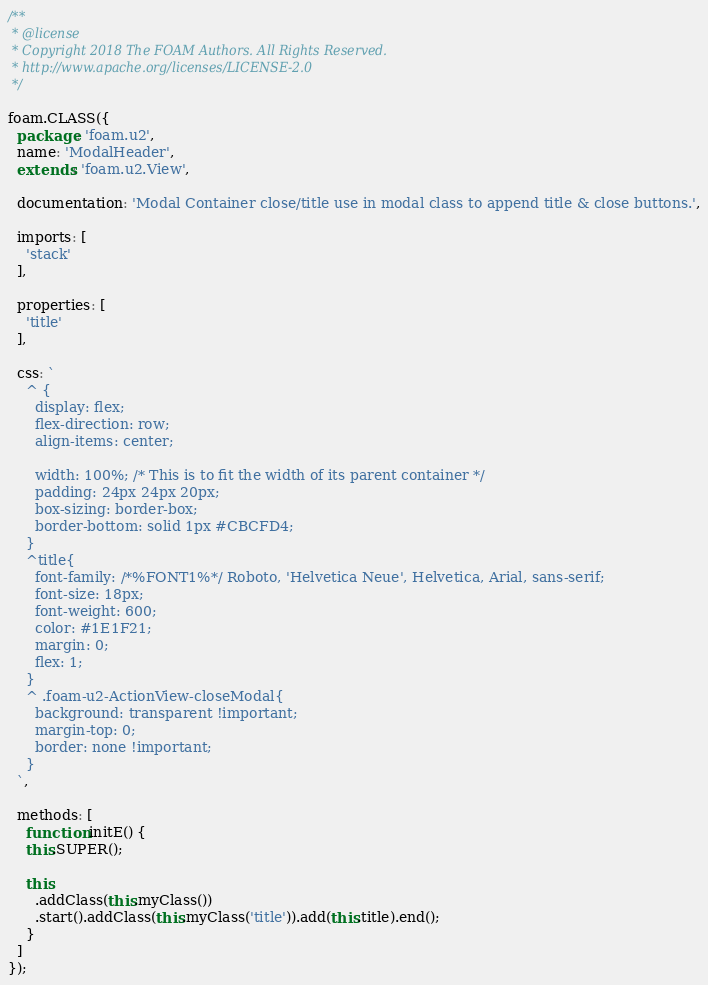<code> <loc_0><loc_0><loc_500><loc_500><_JavaScript_>/**
 * @license
 * Copyright 2018 The FOAM Authors. All Rights Reserved.
 * http://www.apache.org/licenses/LICENSE-2.0
 */

foam.CLASS({
  package: 'foam.u2',
  name: 'ModalHeader',
  extends: 'foam.u2.View',

  documentation: 'Modal Container close/title use in modal class to append title & close buttons.',

  imports: [
    'stack'
  ],

  properties: [
    'title'
  ],

  css: `
    ^ {
      display: flex;
      flex-direction: row;
      align-items: center;

      width: 100%; /* This is to fit the width of its parent container */
      padding: 24px 24px 20px;
      box-sizing: border-box;
      border-bottom: solid 1px #CBCFD4;
    }
    ^title{
      font-family: /*%FONT1%*/ Roboto, 'Helvetica Neue', Helvetica, Arial, sans-serif;
      font-size: 18px;
      font-weight: 600;
      color: #1E1F21;
      margin: 0;
      flex: 1;
    }
    ^ .foam-u2-ActionView-closeModal{
      background: transparent !important;
      margin-top: 0;
      border: none !important;
    }
  `,

  methods: [
    function initE() {
    this.SUPER();

    this
      .addClass(this.myClass())
      .start().addClass(this.myClass('title')).add(this.title).end();
    }
  ]
});
</code> 